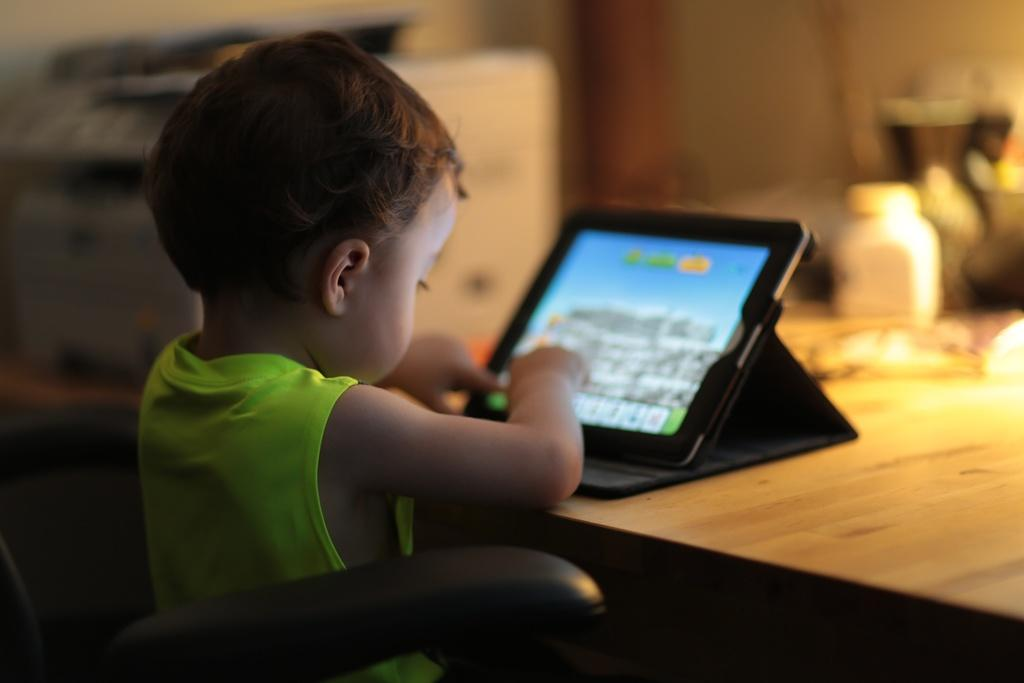What is the main subject of the image? The main subject of the image is a kid. What is the kid doing in the image? The kid is sitting in a chair and playing with a tablet. Where is the tablet placed in the image? The tablet is placed on a table. Can you describe anything in the background of the image? There is a bottle visible in the background of the image. What type of yard can be seen in the image? There is no yard present in the image; it features a kid sitting in a chair and playing with a tablet. Can you describe the veins in the kid's hands while playing with the tablet? There is no information about the kid's veins in the image, as it focuses on the kid's actions and the tablet. 